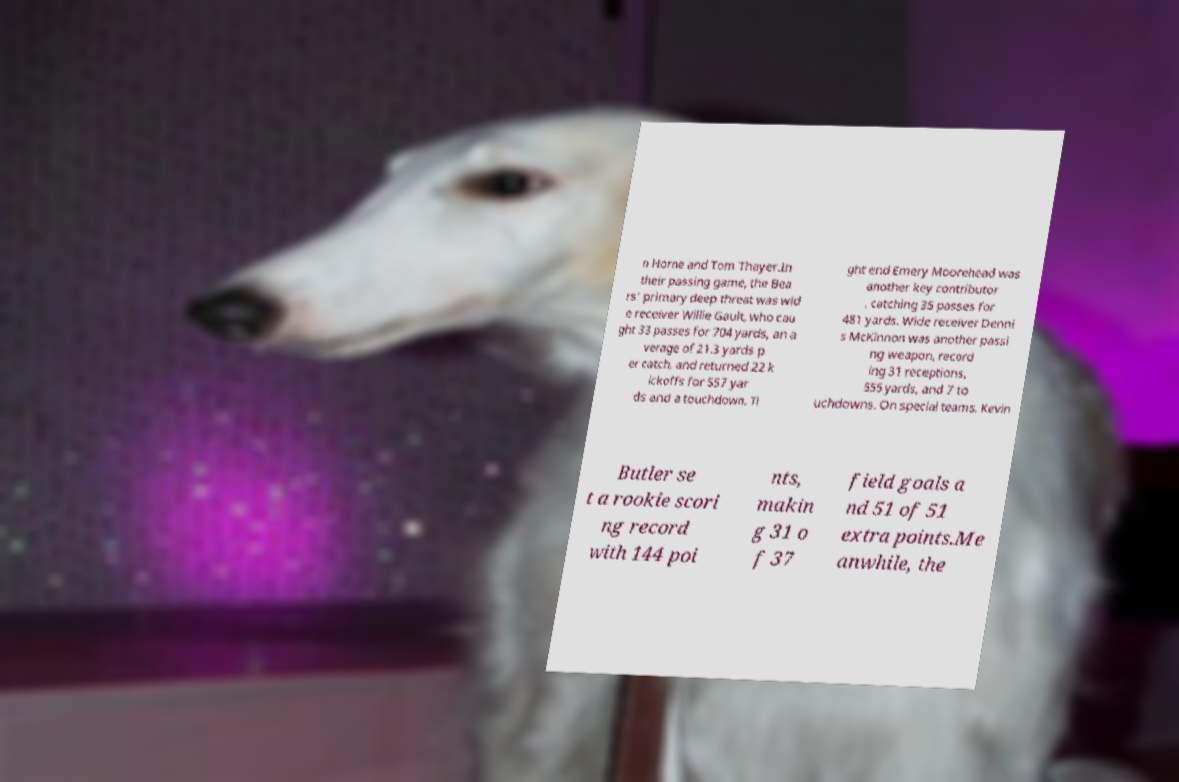What messages or text are displayed in this image? I need them in a readable, typed format. n Horne and Tom Thayer.In their passing game, the Bea rs' primary deep threat was wid e receiver Willie Gault, who cau ght 33 passes for 704 yards, an a verage of 21.3 yards p er catch, and returned 22 k ickoffs for 557 yar ds and a touchdown. Ti ght end Emery Moorehead was another key contributor , catching 35 passes for 481 yards. Wide receiver Denni s McKinnon was another passi ng weapon, record ing 31 receptions, 555 yards, and 7 to uchdowns. On special teams, Kevin Butler se t a rookie scori ng record with 144 poi nts, makin g 31 o f 37 field goals a nd 51 of 51 extra points.Me anwhile, the 